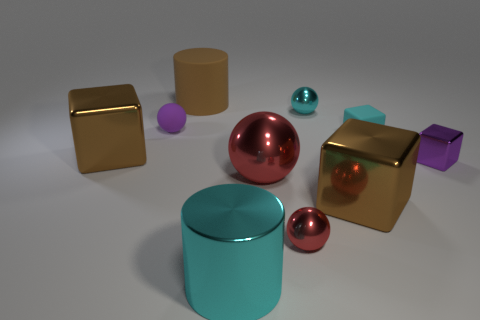Subtract all blocks. How many objects are left? 6 Add 5 spheres. How many spheres exist? 9 Subtract 0 blue balls. How many objects are left? 10 Subtract all big spheres. Subtract all small purple cubes. How many objects are left? 8 Add 5 tiny cyan things. How many tiny cyan things are left? 7 